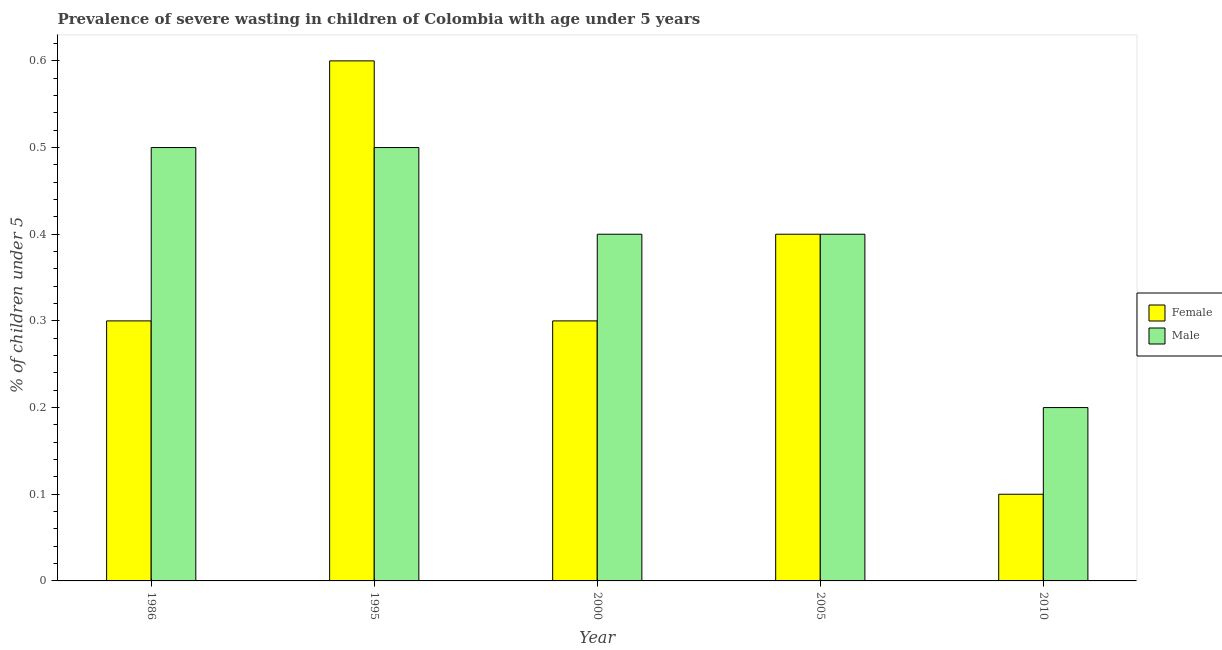How many bars are there on the 1st tick from the right?
Your answer should be very brief. 2. What is the label of the 4th group of bars from the left?
Your answer should be very brief. 2005. In how many cases, is the number of bars for a given year not equal to the number of legend labels?
Make the answer very short. 0. Across all years, what is the maximum percentage of undernourished female children?
Your response must be concise. 0.6. Across all years, what is the minimum percentage of undernourished female children?
Offer a very short reply. 0.1. In which year was the percentage of undernourished female children maximum?
Your answer should be compact. 1995. What is the total percentage of undernourished female children in the graph?
Your response must be concise. 1.7. What is the difference between the percentage of undernourished male children in 1986 and that in 2005?
Your response must be concise. 0.1. What is the difference between the percentage of undernourished male children in 1995 and the percentage of undernourished female children in 2010?
Keep it short and to the point. 0.3. What is the average percentage of undernourished female children per year?
Your answer should be compact. 0.34. What is the ratio of the percentage of undernourished female children in 1986 to that in 1995?
Keep it short and to the point. 0.5. Is the percentage of undernourished male children in 1986 less than that in 2005?
Your answer should be very brief. No. What is the difference between the highest and the second highest percentage of undernourished female children?
Offer a terse response. 0.2. What is the difference between the highest and the lowest percentage of undernourished female children?
Make the answer very short. 0.5. How many years are there in the graph?
Provide a short and direct response. 5. Does the graph contain any zero values?
Provide a succinct answer. No. Where does the legend appear in the graph?
Your answer should be compact. Center right. How are the legend labels stacked?
Offer a terse response. Vertical. What is the title of the graph?
Make the answer very short. Prevalence of severe wasting in children of Colombia with age under 5 years. What is the label or title of the X-axis?
Make the answer very short. Year. What is the label or title of the Y-axis?
Give a very brief answer.  % of children under 5. What is the  % of children under 5 in Female in 1986?
Provide a succinct answer. 0.3. What is the  % of children under 5 of Female in 1995?
Offer a terse response. 0.6. What is the  % of children under 5 of Male in 1995?
Keep it short and to the point. 0.5. What is the  % of children under 5 of Female in 2000?
Provide a succinct answer. 0.3. What is the  % of children under 5 of Male in 2000?
Give a very brief answer. 0.4. What is the  % of children under 5 in Female in 2005?
Provide a short and direct response. 0.4. What is the  % of children under 5 of Male in 2005?
Offer a very short reply. 0.4. What is the  % of children under 5 in Female in 2010?
Keep it short and to the point. 0.1. What is the  % of children under 5 in Male in 2010?
Provide a short and direct response. 0.2. Across all years, what is the maximum  % of children under 5 in Female?
Your response must be concise. 0.6. Across all years, what is the maximum  % of children under 5 in Male?
Your response must be concise. 0.5. Across all years, what is the minimum  % of children under 5 of Female?
Ensure brevity in your answer.  0.1. Across all years, what is the minimum  % of children under 5 in Male?
Your response must be concise. 0.2. What is the total  % of children under 5 in Female in the graph?
Your response must be concise. 1.7. What is the total  % of children under 5 of Male in the graph?
Make the answer very short. 2. What is the difference between the  % of children under 5 of Male in 1986 and that in 1995?
Your answer should be compact. 0. What is the difference between the  % of children under 5 of Female in 1986 and that in 2000?
Provide a short and direct response. 0. What is the difference between the  % of children under 5 in Female in 1986 and that in 2005?
Offer a terse response. -0.1. What is the difference between the  % of children under 5 of Male in 1986 and that in 2010?
Provide a succinct answer. 0.3. What is the difference between the  % of children under 5 in Female in 1995 and that in 2000?
Your response must be concise. 0.3. What is the difference between the  % of children under 5 of Female in 2000 and that in 2005?
Provide a short and direct response. -0.1. What is the difference between the  % of children under 5 in Female in 2000 and that in 2010?
Your answer should be very brief. 0.2. What is the difference between the  % of children under 5 in Male in 2005 and that in 2010?
Your answer should be compact. 0.2. What is the difference between the  % of children under 5 in Female in 1986 and the  % of children under 5 in Male in 2000?
Ensure brevity in your answer.  -0.1. What is the difference between the  % of children under 5 in Female in 1986 and the  % of children under 5 in Male in 2010?
Provide a succinct answer. 0.1. What is the difference between the  % of children under 5 in Female in 1995 and the  % of children under 5 in Male in 2000?
Your response must be concise. 0.2. What is the average  % of children under 5 in Female per year?
Offer a terse response. 0.34. What is the average  % of children under 5 in Male per year?
Your response must be concise. 0.4. What is the ratio of the  % of children under 5 in Female in 1986 to that in 1995?
Keep it short and to the point. 0.5. What is the ratio of the  % of children under 5 of Male in 1986 to that in 1995?
Offer a terse response. 1. What is the ratio of the  % of children under 5 in Female in 1986 to that in 2000?
Your answer should be compact. 1. What is the ratio of the  % of children under 5 of Male in 1986 to that in 2010?
Make the answer very short. 2.5. What is the ratio of the  % of children under 5 of Male in 1995 to that in 2000?
Your response must be concise. 1.25. What is the ratio of the  % of children under 5 in Male in 1995 to that in 2005?
Make the answer very short. 1.25. What is the ratio of the  % of children under 5 of Male in 1995 to that in 2010?
Provide a succinct answer. 2.5. What is the ratio of the  % of children under 5 in Male in 2000 to that in 2010?
Offer a very short reply. 2. What is the difference between the highest and the lowest  % of children under 5 in Female?
Offer a very short reply. 0.5. What is the difference between the highest and the lowest  % of children under 5 of Male?
Your answer should be very brief. 0.3. 